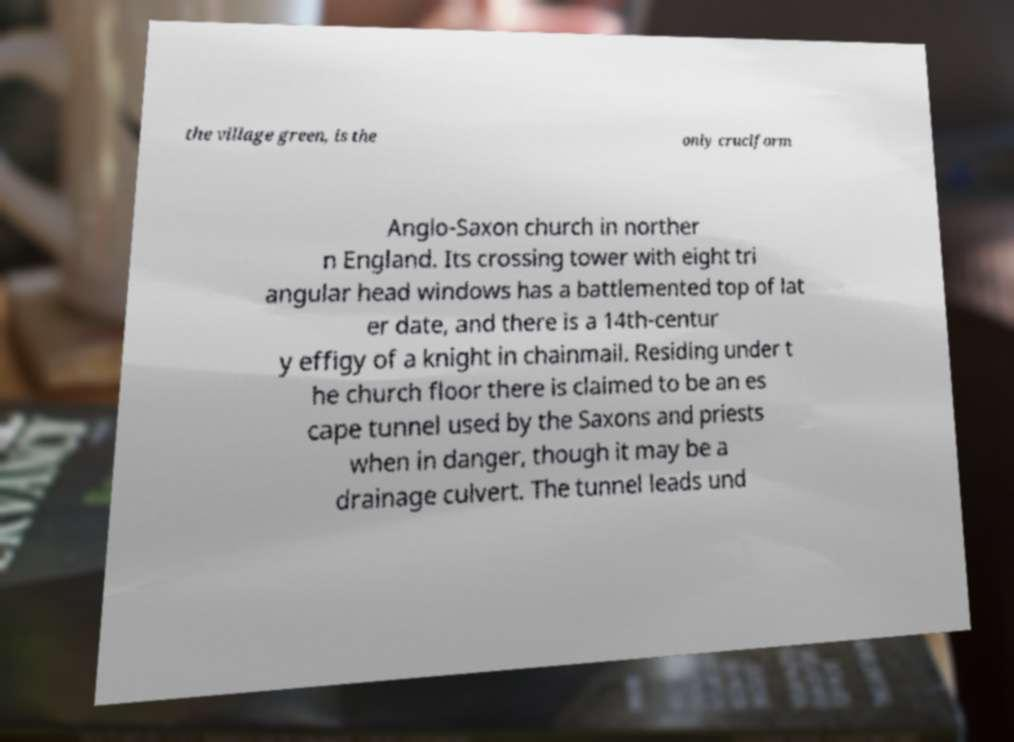Could you extract and type out the text from this image? the village green, is the only cruciform Anglo-Saxon church in norther n England. Its crossing tower with eight tri angular head windows has a battlemented top of lat er date, and there is a 14th-centur y effigy of a knight in chainmail. Residing under t he church floor there is claimed to be an es cape tunnel used by the Saxons and priests when in danger, though it may be a drainage culvert. The tunnel leads und 